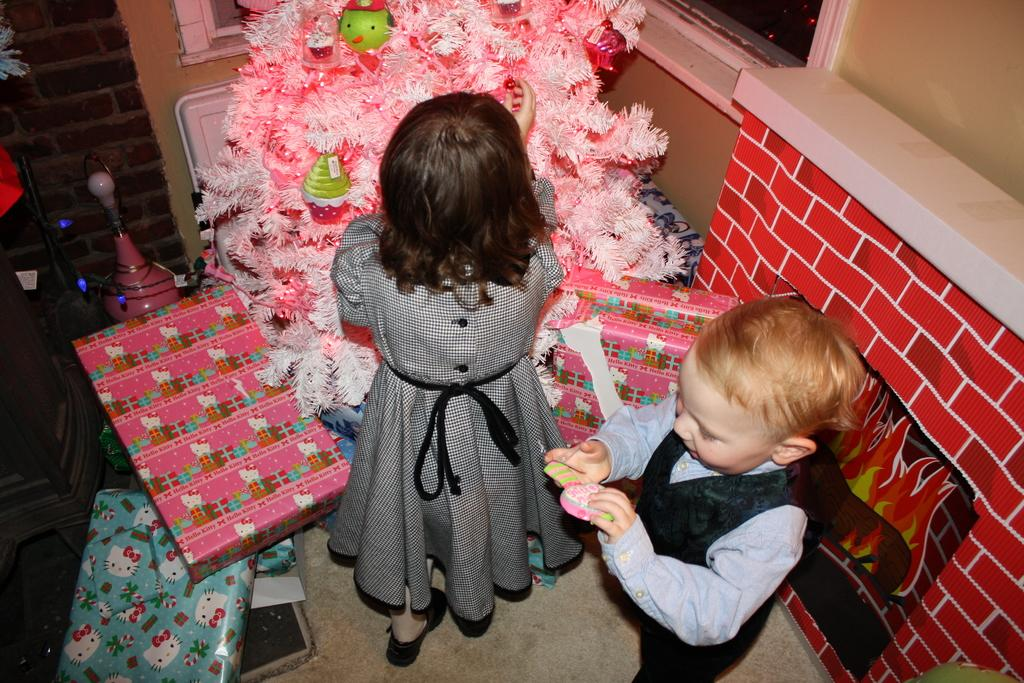How many kids are visible in the image? There are two kids standing in the image. Where are the kids standing? The kids are standing on the floor. What can be seen in the background of the image? There is a wall, a tree, boxes, and other objects in the background of the image. What type of whip is being used by the kids in the image? There is no whip present in the image; the kids are simply standing on the floor. 